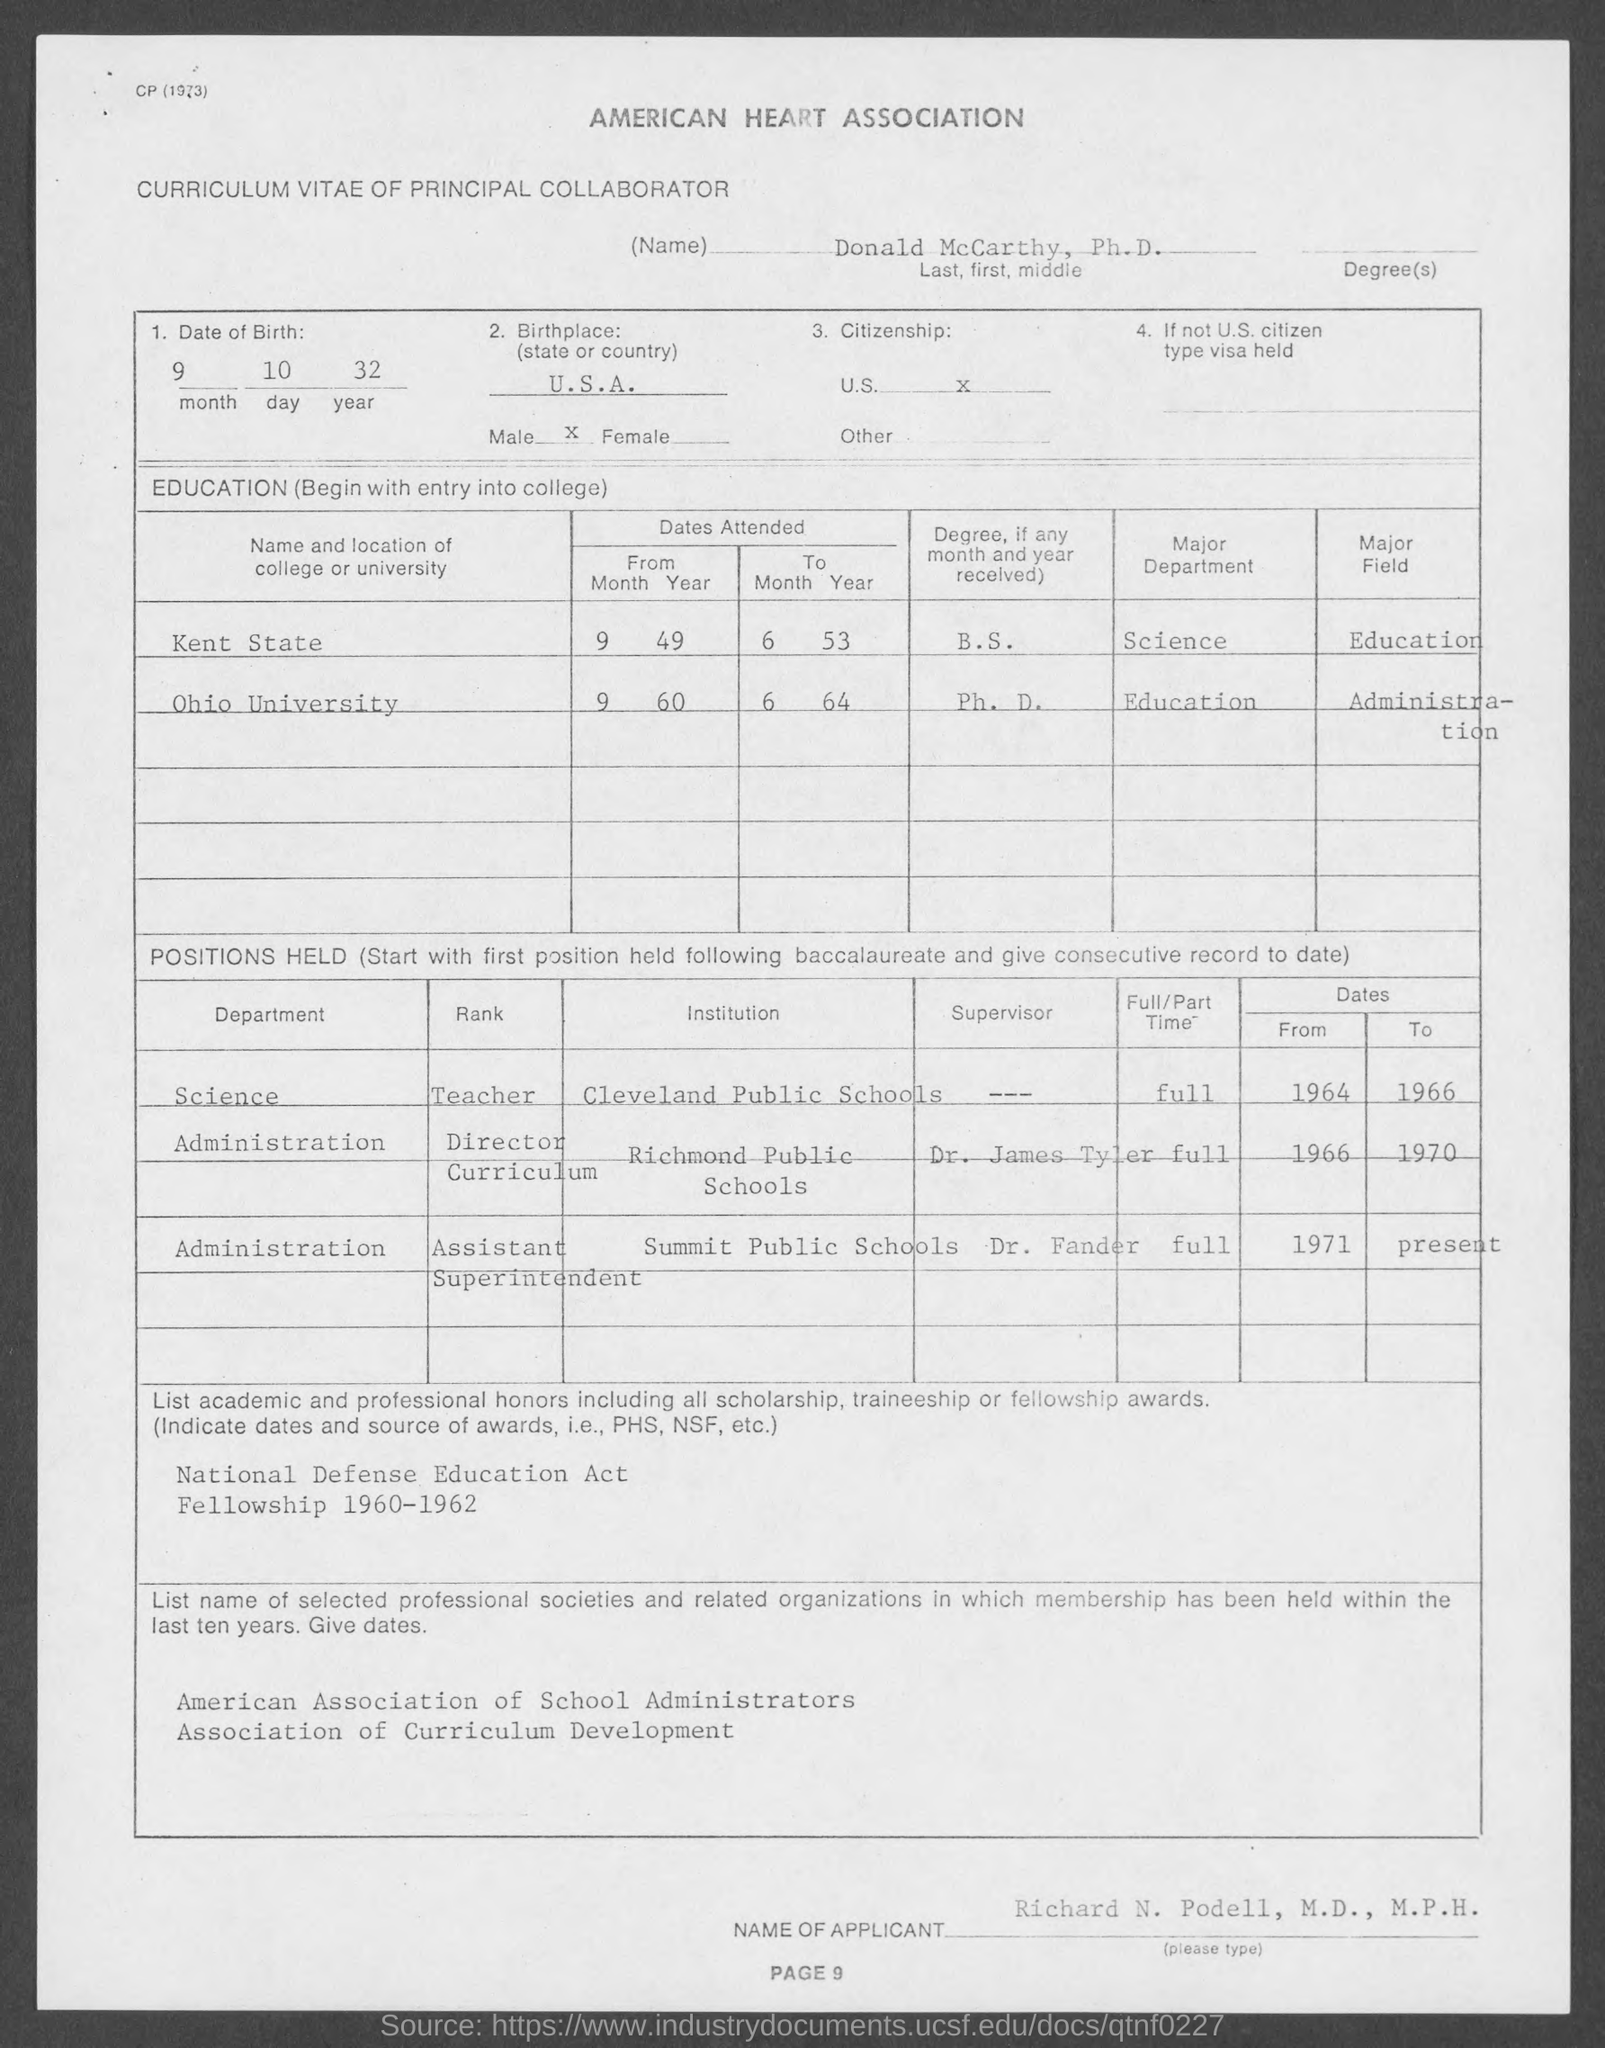Which heart association name is given at the top?
Offer a terse response. American heart association. What is the Date of Birth?
Ensure brevity in your answer.  9 10 32. 